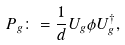<formula> <loc_0><loc_0><loc_500><loc_500>P _ { g } \colon = \frac { 1 } { d } U _ { g } \phi U _ { g } ^ { \dag } ,</formula> 